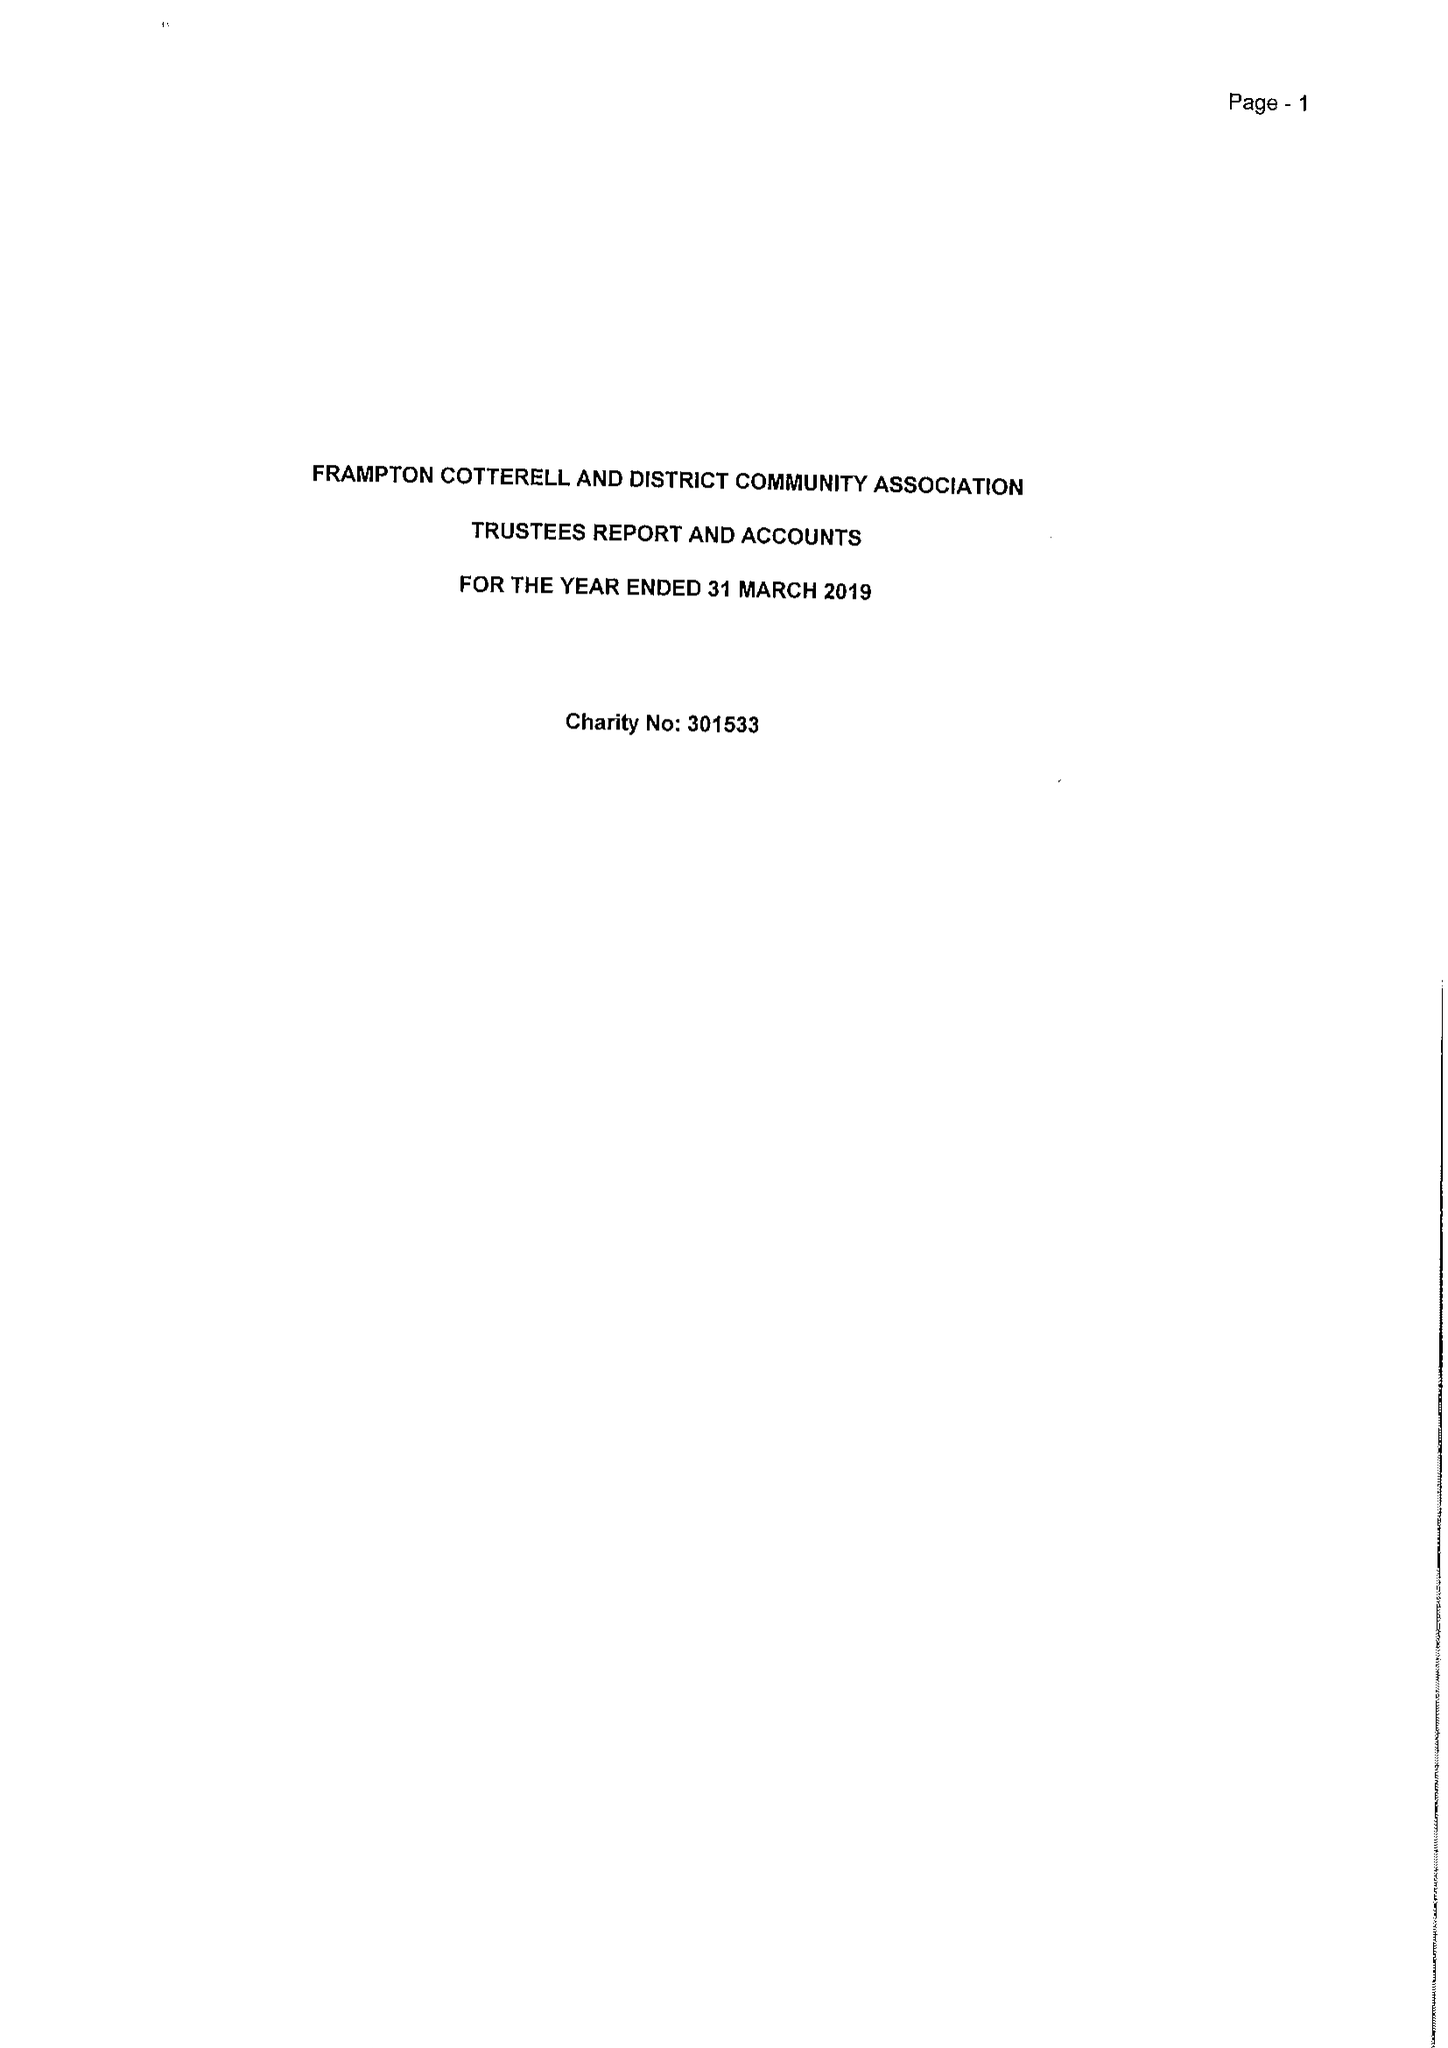What is the value for the address__postcode?
Answer the question using a single word or phrase. BS36 2DB 